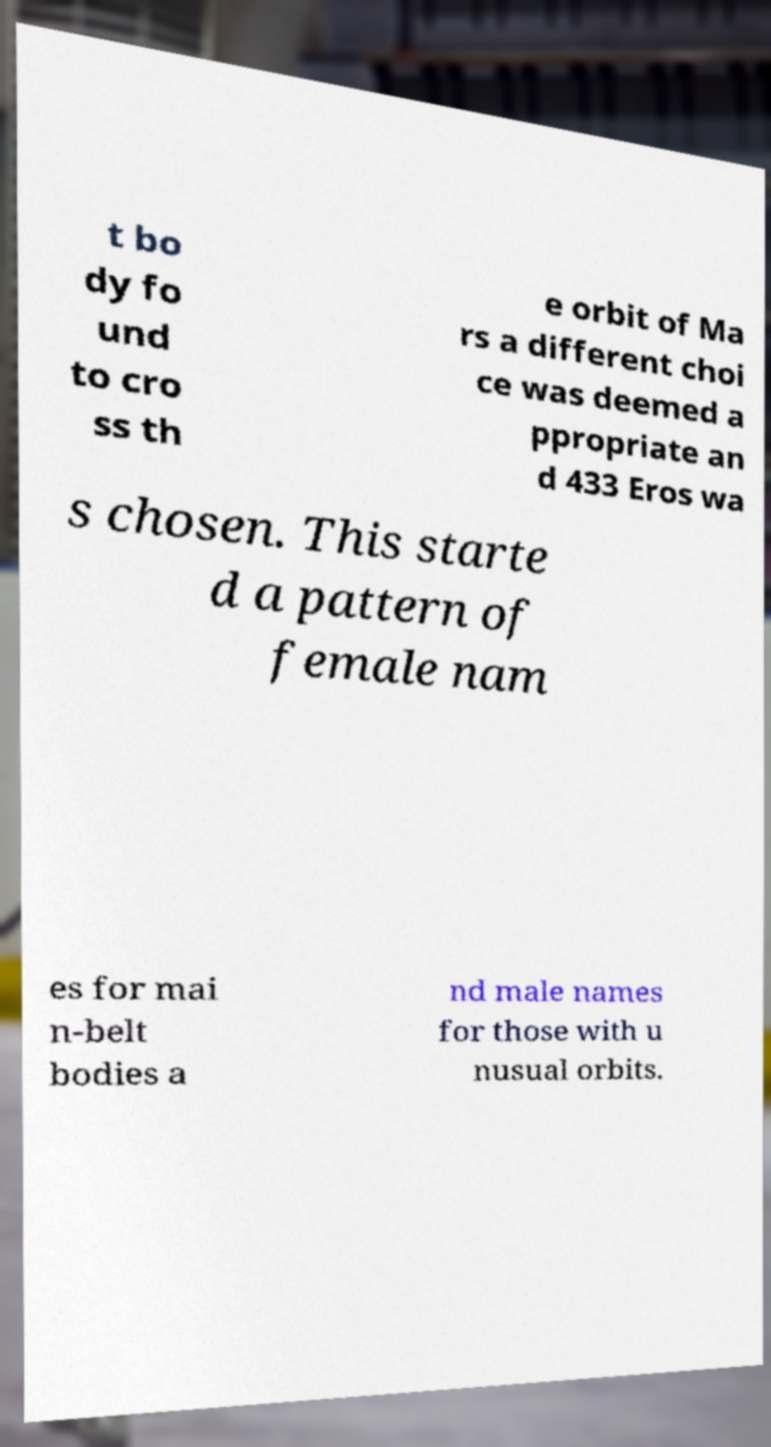Could you assist in decoding the text presented in this image and type it out clearly? t bo dy fo und to cro ss th e orbit of Ma rs a different choi ce was deemed a ppropriate an d 433 Eros wa s chosen. This starte d a pattern of female nam es for mai n-belt bodies a nd male names for those with u nusual orbits. 